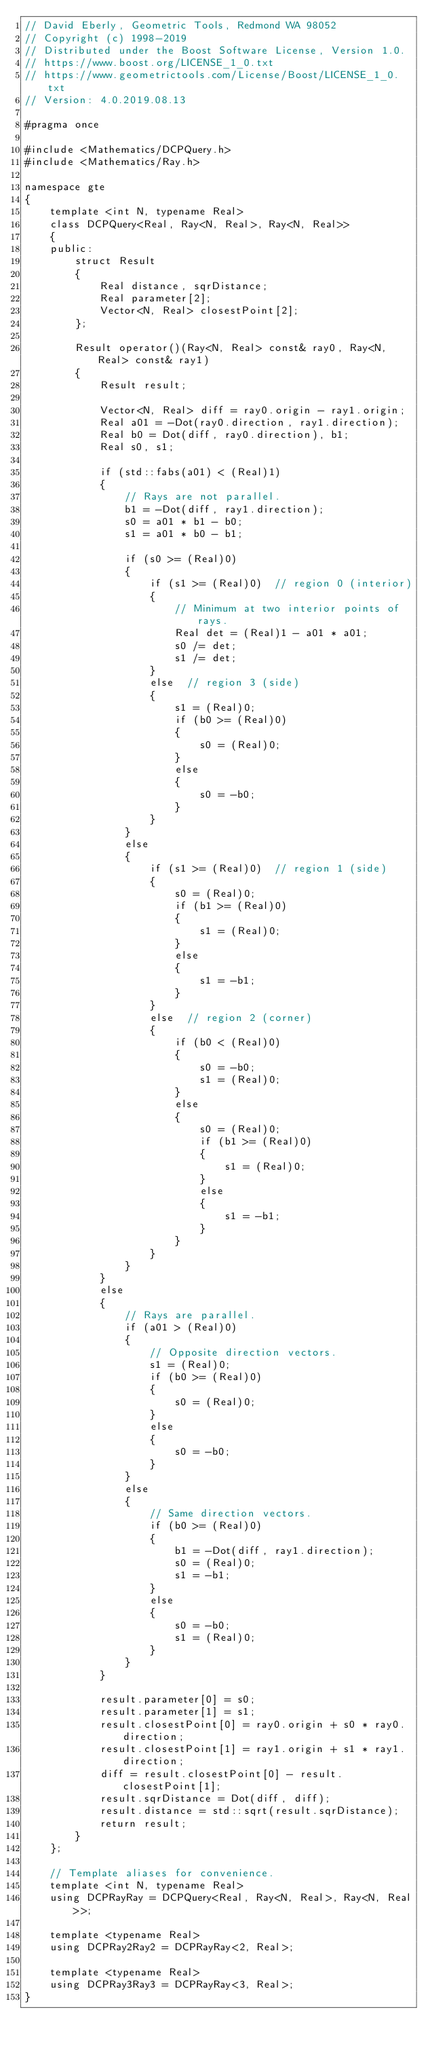<code> <loc_0><loc_0><loc_500><loc_500><_C_>// David Eberly, Geometric Tools, Redmond WA 98052
// Copyright (c) 1998-2019
// Distributed under the Boost Software License, Version 1.0.
// https://www.boost.org/LICENSE_1_0.txt
// https://www.geometrictools.com/License/Boost/LICENSE_1_0.txt
// Version: 4.0.2019.08.13

#pragma once

#include <Mathematics/DCPQuery.h>
#include <Mathematics/Ray.h>

namespace gte
{
    template <int N, typename Real>
    class DCPQuery<Real, Ray<N, Real>, Ray<N, Real>>
    {
    public:
        struct Result
        {
            Real distance, sqrDistance;
            Real parameter[2];
            Vector<N, Real> closestPoint[2];
        };

        Result operator()(Ray<N, Real> const& ray0, Ray<N, Real> const& ray1)
        {
            Result result;

            Vector<N, Real> diff = ray0.origin - ray1.origin;
            Real a01 = -Dot(ray0.direction, ray1.direction);
            Real b0 = Dot(diff, ray0.direction), b1;
            Real s0, s1;

            if (std::fabs(a01) < (Real)1)
            {
                // Rays are not parallel.
                b1 = -Dot(diff, ray1.direction);
                s0 = a01 * b1 - b0;
                s1 = a01 * b0 - b1;

                if (s0 >= (Real)0)
                {
                    if (s1 >= (Real)0)  // region 0 (interior)
                    {
                        // Minimum at two interior points of rays.
                        Real det = (Real)1 - a01 * a01;
                        s0 /= det;
                        s1 /= det;
                    }
                    else  // region 3 (side)
                    {
                        s1 = (Real)0;
                        if (b0 >= (Real)0)
                        {
                            s0 = (Real)0;
                        }
                        else
                        {
                            s0 = -b0;
                        }
                    }
                }
                else
                {
                    if (s1 >= (Real)0)  // region 1 (side)
                    {
                        s0 = (Real)0;
                        if (b1 >= (Real)0)
                        {
                            s1 = (Real)0;
                        }
                        else
                        {
                            s1 = -b1;
                        }
                    }
                    else  // region 2 (corner)
                    {
                        if (b0 < (Real)0)
                        {
                            s0 = -b0;
                            s1 = (Real)0;
                        }
                        else
                        {
                            s0 = (Real)0;
                            if (b1 >= (Real)0)
                            {
                                s1 = (Real)0;
                            }
                            else
                            {
                                s1 = -b1;
                            }
                        }
                    }
                }
            }
            else
            {
                // Rays are parallel.
                if (a01 > (Real)0)
                {
                    // Opposite direction vectors.
                    s1 = (Real)0;
                    if (b0 >= (Real)0)
                    {
                        s0 = (Real)0;
                    }
                    else
                    {
                        s0 = -b0;
                    }
                }
                else
                {
                    // Same direction vectors.
                    if (b0 >= (Real)0)
                    {
                        b1 = -Dot(diff, ray1.direction);
                        s0 = (Real)0;
                        s1 = -b1;
                    }
                    else
                    {
                        s0 = -b0;
                        s1 = (Real)0;
                    }
                }
            }

            result.parameter[0] = s0;
            result.parameter[1] = s1;
            result.closestPoint[0] = ray0.origin + s0 * ray0.direction;
            result.closestPoint[1] = ray1.origin + s1 * ray1.direction;
            diff = result.closestPoint[0] - result.closestPoint[1];
            result.sqrDistance = Dot(diff, diff);
            result.distance = std::sqrt(result.sqrDistance);
            return result;
        }
    };

    // Template aliases for convenience.
    template <int N, typename Real>
    using DCPRayRay = DCPQuery<Real, Ray<N, Real>, Ray<N, Real>>;

    template <typename Real>
    using DCPRay2Ray2 = DCPRayRay<2, Real>;

    template <typename Real>
    using DCPRay3Ray3 = DCPRayRay<3, Real>;
}
</code> 